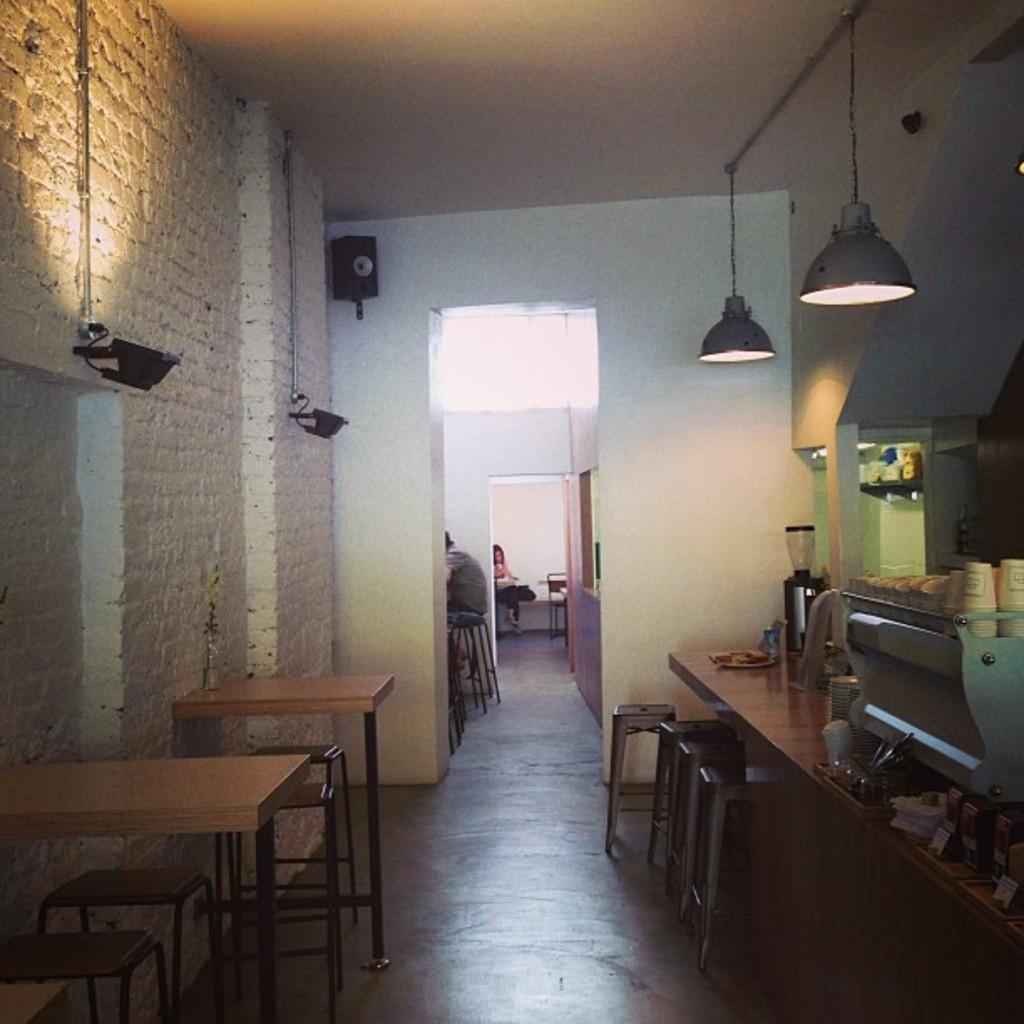What type of furniture is visible in the image? There are tables and stools on the floor in the image. What is the wooden structure in the image used for? There is a wooden platform in the image, which could be used for various purposes such as a stage or a display area. What can be seen hanging from the ceiling in the image? There are lights in the image. What is present in the background of the image? There is a wall, a speaker, a roof, and people in the background of the image. Can you see any worms crawling on the wooden platform in the image? There are no worms present in the image; it only features tables, stools, a wooden platform, lights, and objects. Are there any cobwebs visible on the roof in the image? There is no mention of cobwebs in the image; it only features a roof, a wall, a speaker, and people in the background. 